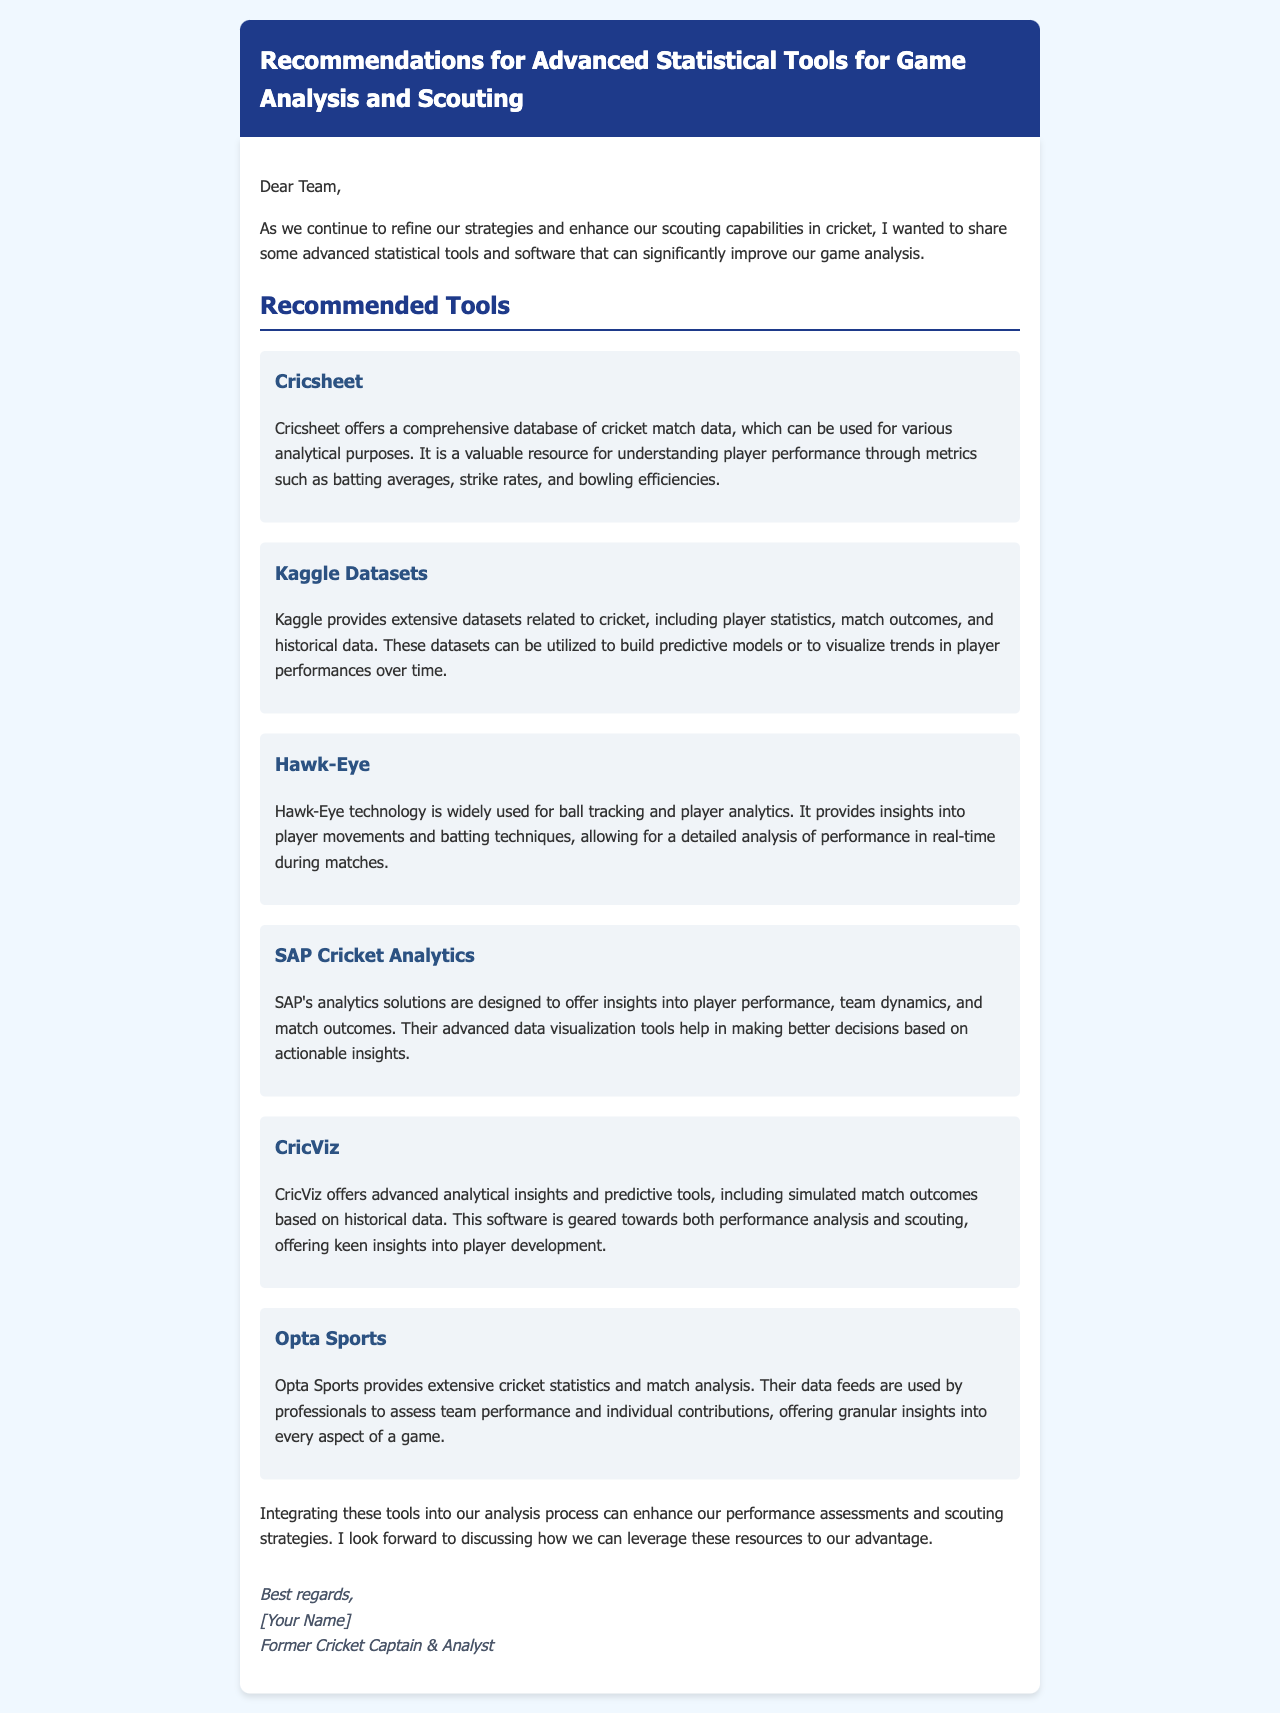What is the title of the document? The title of the document is given in the header section, which reads "Recommendations for Advanced Statistical Tools for Game Analysis and Scouting."
Answer: Recommendations for Advanced Statistical Tools for Game Analysis and Scouting How many recommended tools are listed? The document details six recommended tools under the "Recommended Tools" section.
Answer: Six What is Cricsheet used for? Cricsheet offers a comprehensive database of cricket match data for various analytical purposes, including understanding player performance metrics.
Answer: Understanding player performance Which technology is used for ball tracking? The document mentions Hawk-Eye technology as widely used for ball tracking and player analytics.
Answer: Hawk-Eye What does SAP Cricket Analytics offer? SAP's analytics solutions provide insights into player performance, team dynamics, and match outcomes.
Answer: Insights into player performance What does CricViz provide? CricViz offers advanced analytical insights and predictive tools, including simulated match outcomes based on historical data.
Answer: Advanced analytical insights Who is the sender of the email? The signature section identifies the sender as a "Former Cricket Captain & Analyst."
Answer: Former Cricket Captain & Analyst 